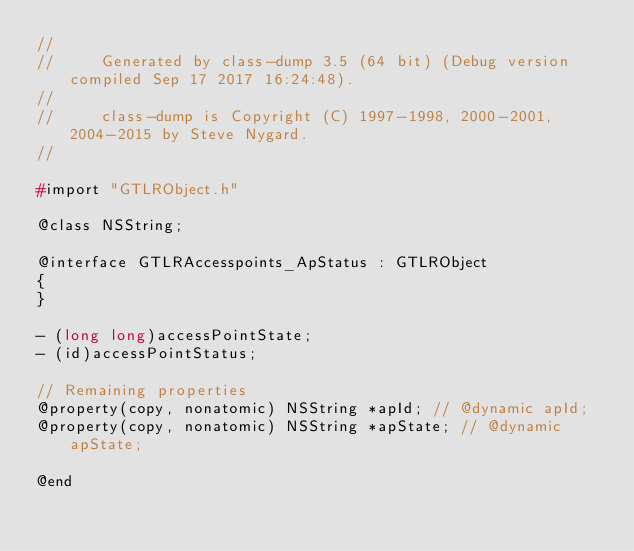Convert code to text. <code><loc_0><loc_0><loc_500><loc_500><_C_>//
//     Generated by class-dump 3.5 (64 bit) (Debug version compiled Sep 17 2017 16:24:48).
//
//     class-dump is Copyright (C) 1997-1998, 2000-2001, 2004-2015 by Steve Nygard.
//

#import "GTLRObject.h"

@class NSString;

@interface GTLRAccesspoints_ApStatus : GTLRObject
{
}

- (long long)accessPointState;
- (id)accessPointStatus;

// Remaining properties
@property(copy, nonatomic) NSString *apId; // @dynamic apId;
@property(copy, nonatomic) NSString *apState; // @dynamic apState;

@end

</code> 